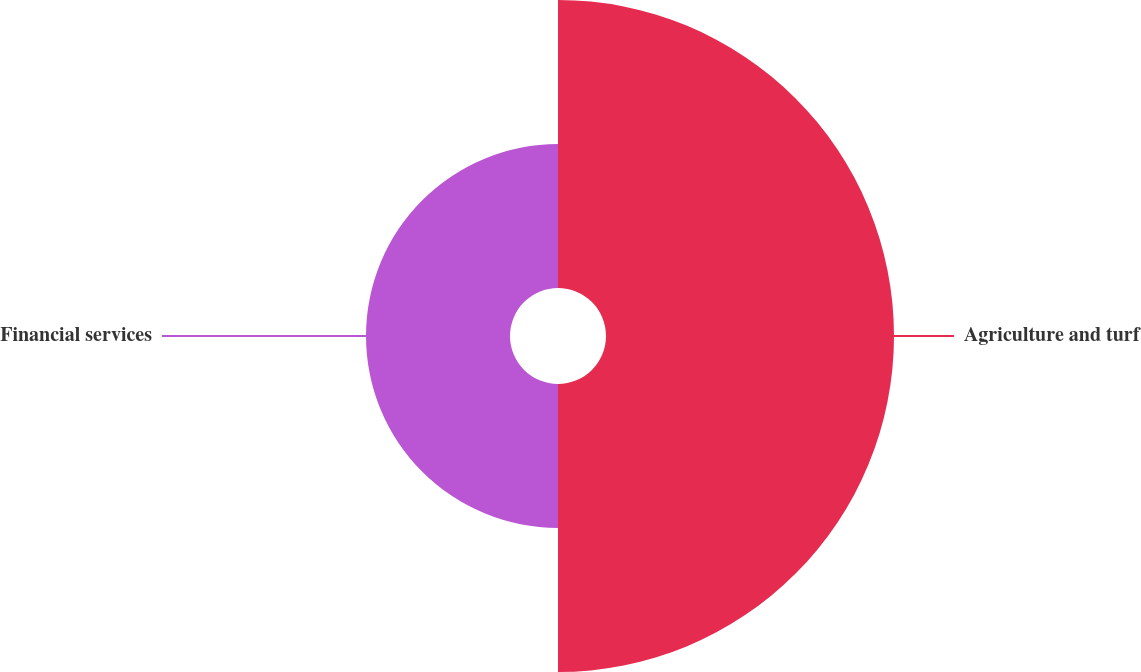<chart> <loc_0><loc_0><loc_500><loc_500><pie_chart><fcel>Agriculture and turf<fcel>Financial services<nl><fcel>66.67%<fcel>33.33%<nl></chart> 